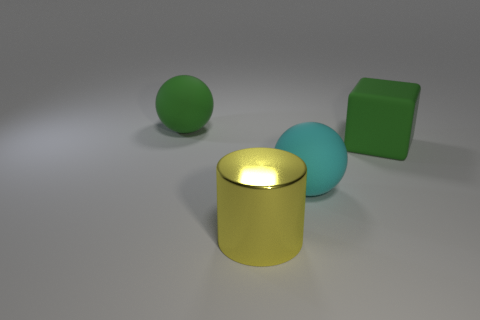What is the color of the other rubber object that is the same shape as the cyan object?
Your answer should be very brief. Green. Are there more large cyan rubber objects that are behind the green sphere than tiny purple balls?
Make the answer very short. No. There is a large matte sphere that is behind the cyan matte object; what is its color?
Provide a succinct answer. Green. Does the cyan rubber ball have the same size as the green rubber ball?
Offer a very short reply. Yes. The green matte ball is what size?
Provide a succinct answer. Large. What shape is the big object that is the same color as the rubber cube?
Offer a very short reply. Sphere. Is the number of large cyan objects greater than the number of tiny green rubber cylinders?
Make the answer very short. Yes. There is a matte thing that is to the right of the matte sphere that is on the right side of the yellow cylinder in front of the cyan sphere; what is its color?
Make the answer very short. Green. Is the shape of the object that is behind the large green rubber block the same as  the large cyan matte object?
Ensure brevity in your answer.  Yes. There is a cylinder that is the same size as the cube; what is its color?
Keep it short and to the point. Yellow. 